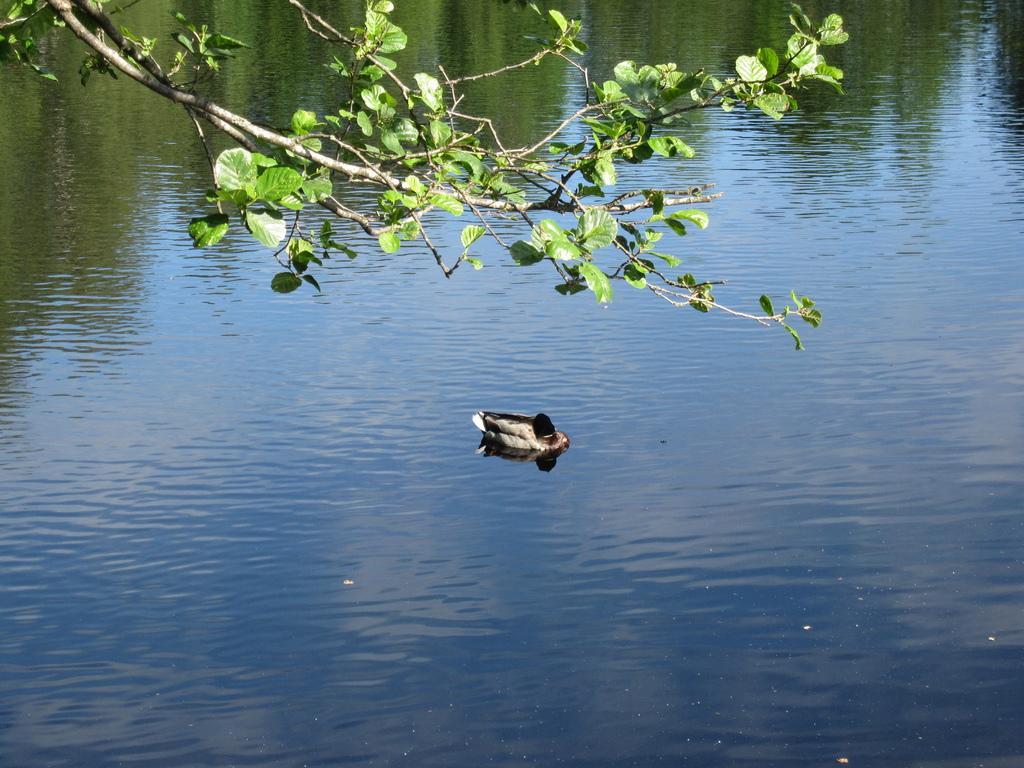Can you describe this image briefly? In this image we can see a bird on the surface of the water. We can also see the leaves and also the stems at the top. 